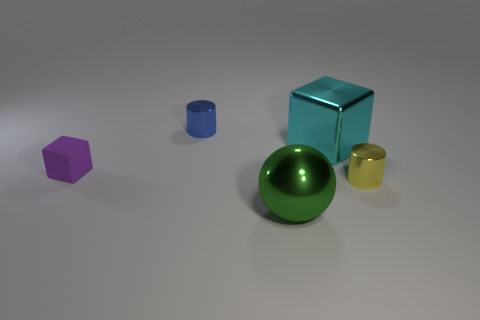Add 4 cyan metal objects. How many objects exist? 9 Subtract all cubes. How many objects are left? 3 Add 2 small cylinders. How many small cylinders are left? 4 Add 2 green metal things. How many green metal things exist? 3 Subtract 0 red spheres. How many objects are left? 5 Subtract all small purple rubber things. Subtract all big spheres. How many objects are left? 3 